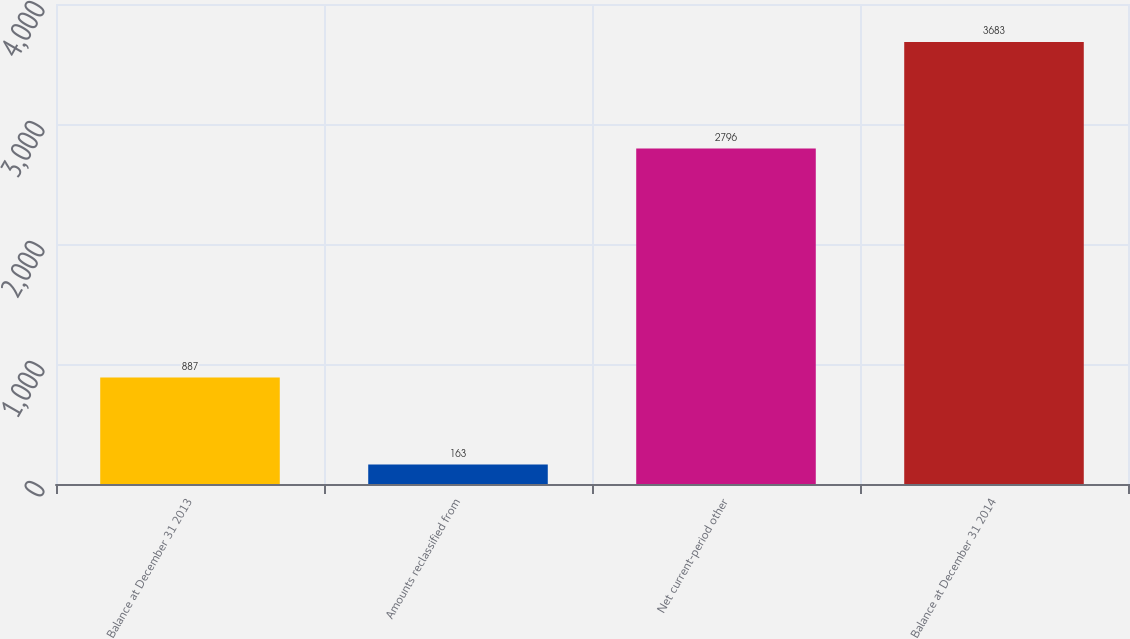Convert chart to OTSL. <chart><loc_0><loc_0><loc_500><loc_500><bar_chart><fcel>Balance at December 31 2013<fcel>Amounts reclassified from<fcel>Net current-period other<fcel>Balance at December 31 2014<nl><fcel>887<fcel>163<fcel>2796<fcel>3683<nl></chart> 